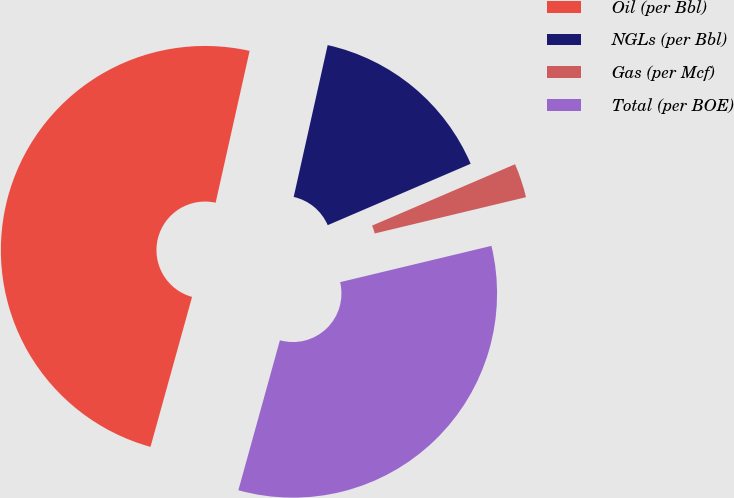Convert chart. <chart><loc_0><loc_0><loc_500><loc_500><pie_chart><fcel>Oil (per Bbl)<fcel>NGLs (per Bbl)<fcel>Gas (per Mcf)<fcel>Total (per BOE)<nl><fcel>49.2%<fcel>15.04%<fcel>2.71%<fcel>33.05%<nl></chart> 